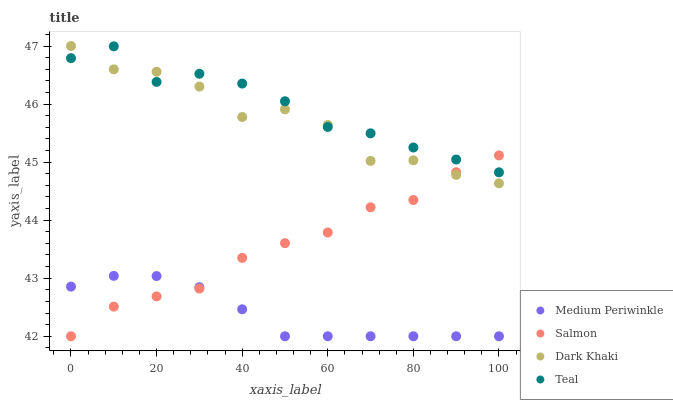Does Medium Periwinkle have the minimum area under the curve?
Answer yes or no. Yes. Does Teal have the maximum area under the curve?
Answer yes or no. Yes. Does Salmon have the minimum area under the curve?
Answer yes or no. No. Does Salmon have the maximum area under the curve?
Answer yes or no. No. Is Medium Periwinkle the smoothest?
Answer yes or no. Yes. Is Dark Khaki the roughest?
Answer yes or no. Yes. Is Salmon the smoothest?
Answer yes or no. No. Is Salmon the roughest?
Answer yes or no. No. Does Salmon have the lowest value?
Answer yes or no. Yes. Does Teal have the lowest value?
Answer yes or no. No. Does Dark Khaki have the highest value?
Answer yes or no. Yes. Does Salmon have the highest value?
Answer yes or no. No. Is Medium Periwinkle less than Dark Khaki?
Answer yes or no. Yes. Is Teal greater than Medium Periwinkle?
Answer yes or no. Yes. Does Salmon intersect Dark Khaki?
Answer yes or no. Yes. Is Salmon less than Dark Khaki?
Answer yes or no. No. Is Salmon greater than Dark Khaki?
Answer yes or no. No. Does Medium Periwinkle intersect Dark Khaki?
Answer yes or no. No. 